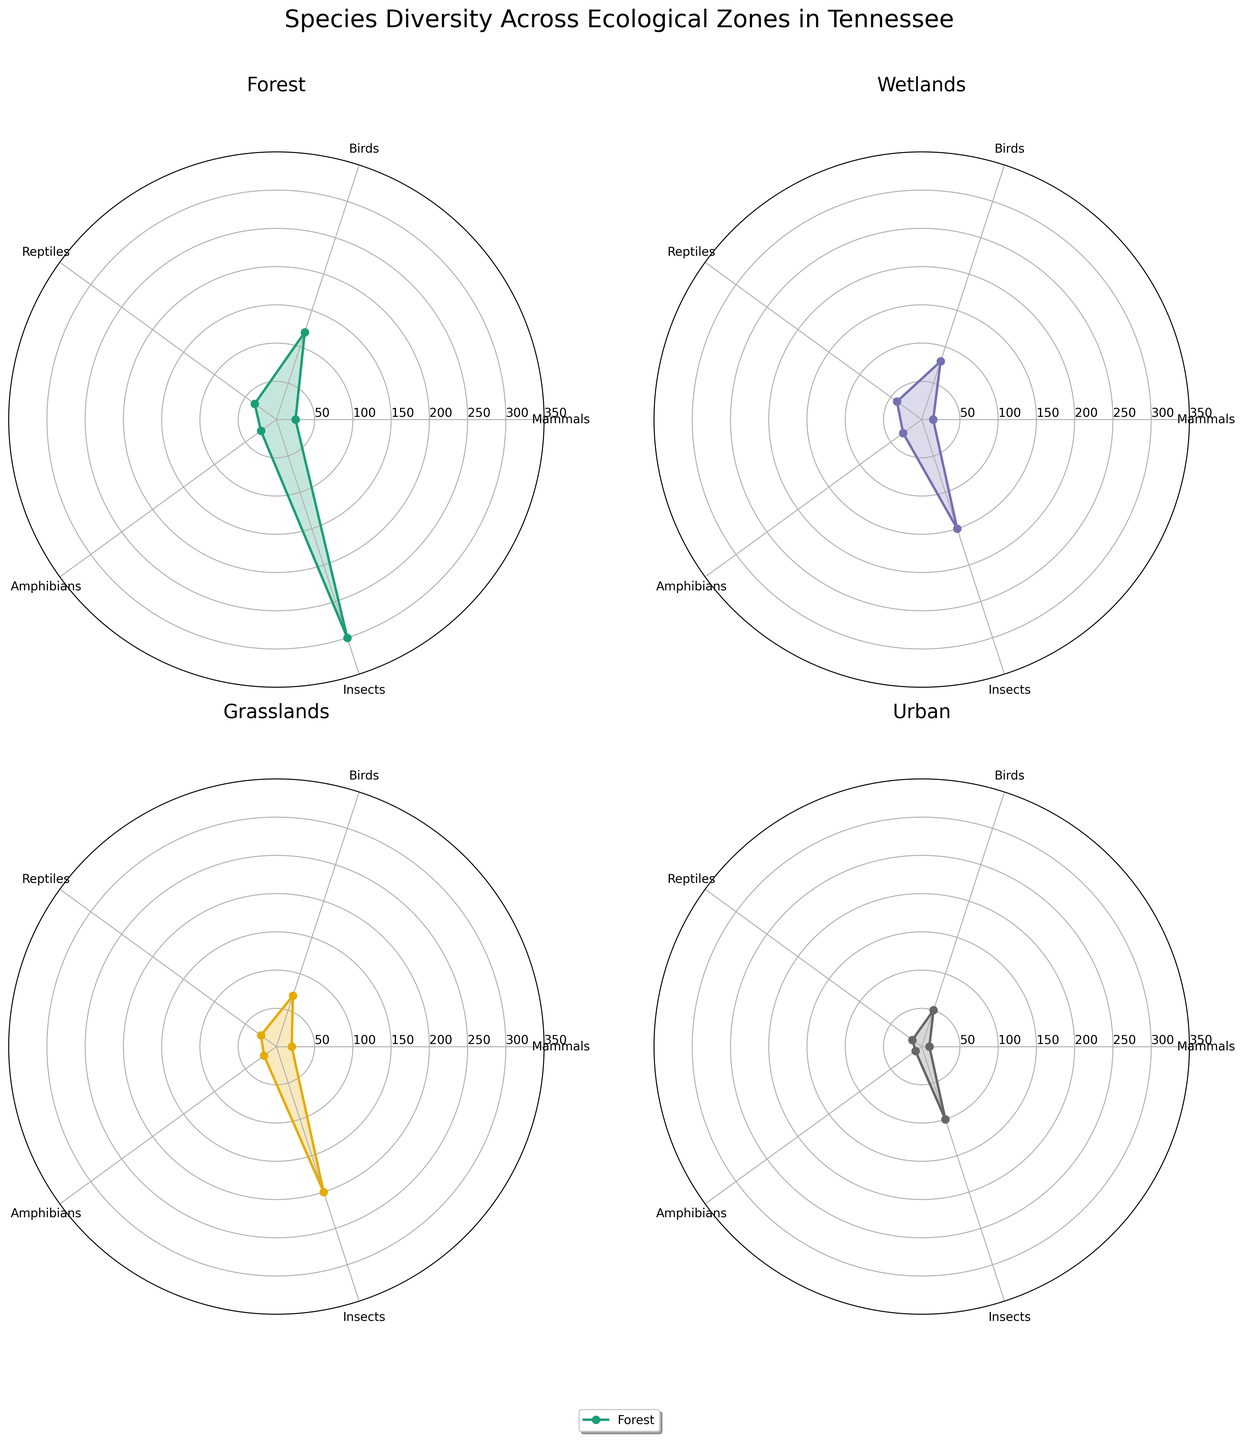What is the ecological zone with the highest number of bird species? By looking at the radar chart in each subplot, you can compare the value of bird species among different ecological zones. Forests have the longest distance from the center for birds, indicating they have the highest count.
Answer: Forest Which species type has the highest diversity in wetlands? Refer to the Wetlands subplot and identify which species type has the highest value. In the wetlands subplot, insects reach the outermost circle, indicating the highest count.
Answer: Insects How many more bird species are in forests compared to grasslands? From the forest's subplot, note the count of birds (120). Then, from the grasslands' subplot, note the count of birds (70). Subtract the two values: 120 - 70 = 50.
Answer: 50 Is the number of reptile species higher in wetlands or urban areas? Observe the parts of the radar charts for reptiles in both the wetlands and urban areas subplots. Wetlands have 40 reptiles, while urban areas have 15.
Answer: Wetlands What is the average number of amphibian species across all ecological zones? Sum the amphibian species counts from each ecological zone: 25 (Forests), 30 (Wetlands), 20 (Grasslands), 10 (Urban). The total is 25 + 30 + 20 + 10 = 85. Divide by the number of zones (4): 85 / 4 = 21.25.
Answer: 21.25 Which ecological zone has the least species diversity for mammals? Evaluate the mammal counts in each subplot. Urban areas have the smallest distance from the center for mammals, indicating they have the lowest count (10).
Answer: Urban Compare the species diversity of insects between forests and grasslands. Which is greater? Check the radar charts for the value of insects in both the forests and grasslands subplots. Forests have 300 insects, while grasslands have 200. Forests have a greater species diversity for insects.
Answer: Forests How does the number of amphibian species in forests compare to the number in wetlands? Look at the plots for amphibians in both the forests and wetlands subplots. Forests have 25 amphibians, and wetlands have 30 amphibians. Therefore, wetlands have more amphibians than forests.
Answer: Wetlands What is the total number of species in urban areas? Sum the species counts for mammals, birds, reptiles, amphibians, and insects in the urban subplot: 10 + 50 + 15 + 10 + 100 = 185.
Answer: 185 